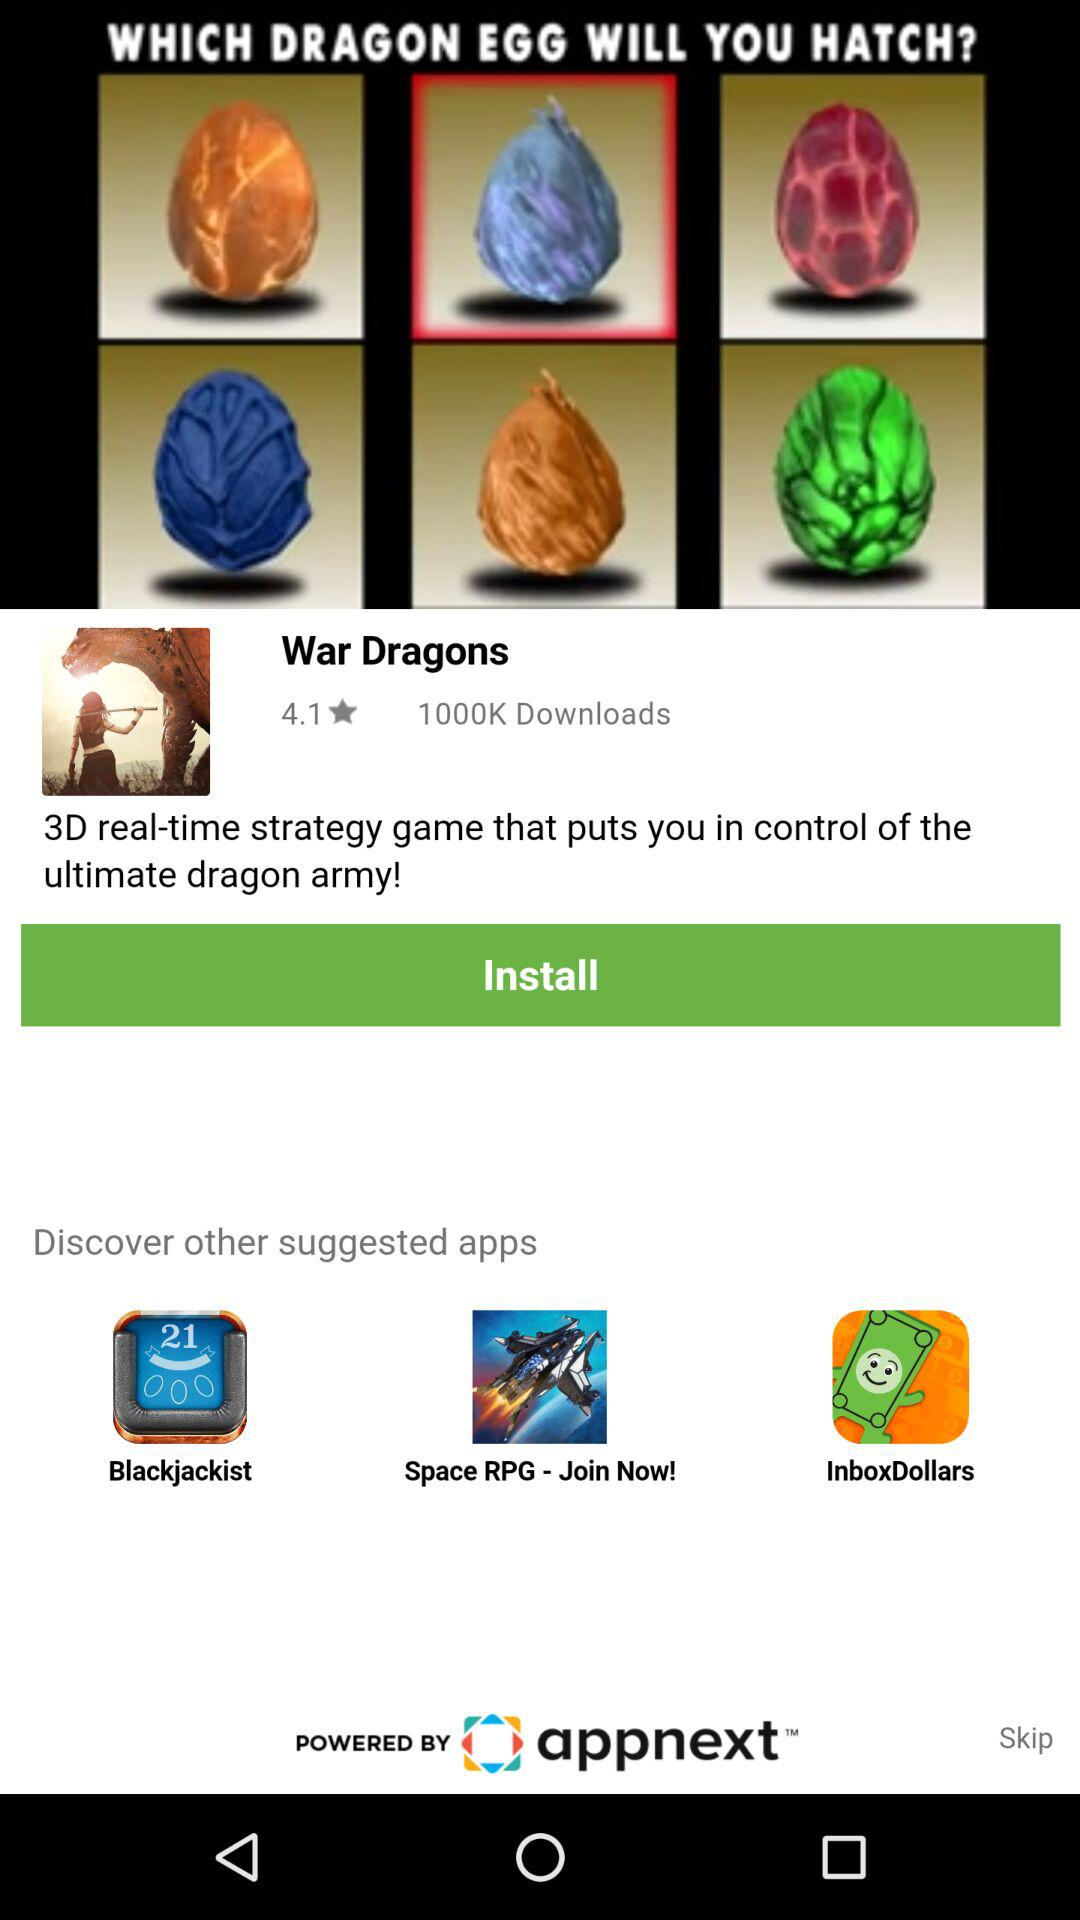Which are the different suggested apps? The different suggested apps are "Blackjackist", "Space RPG" and "InboxDollars". 